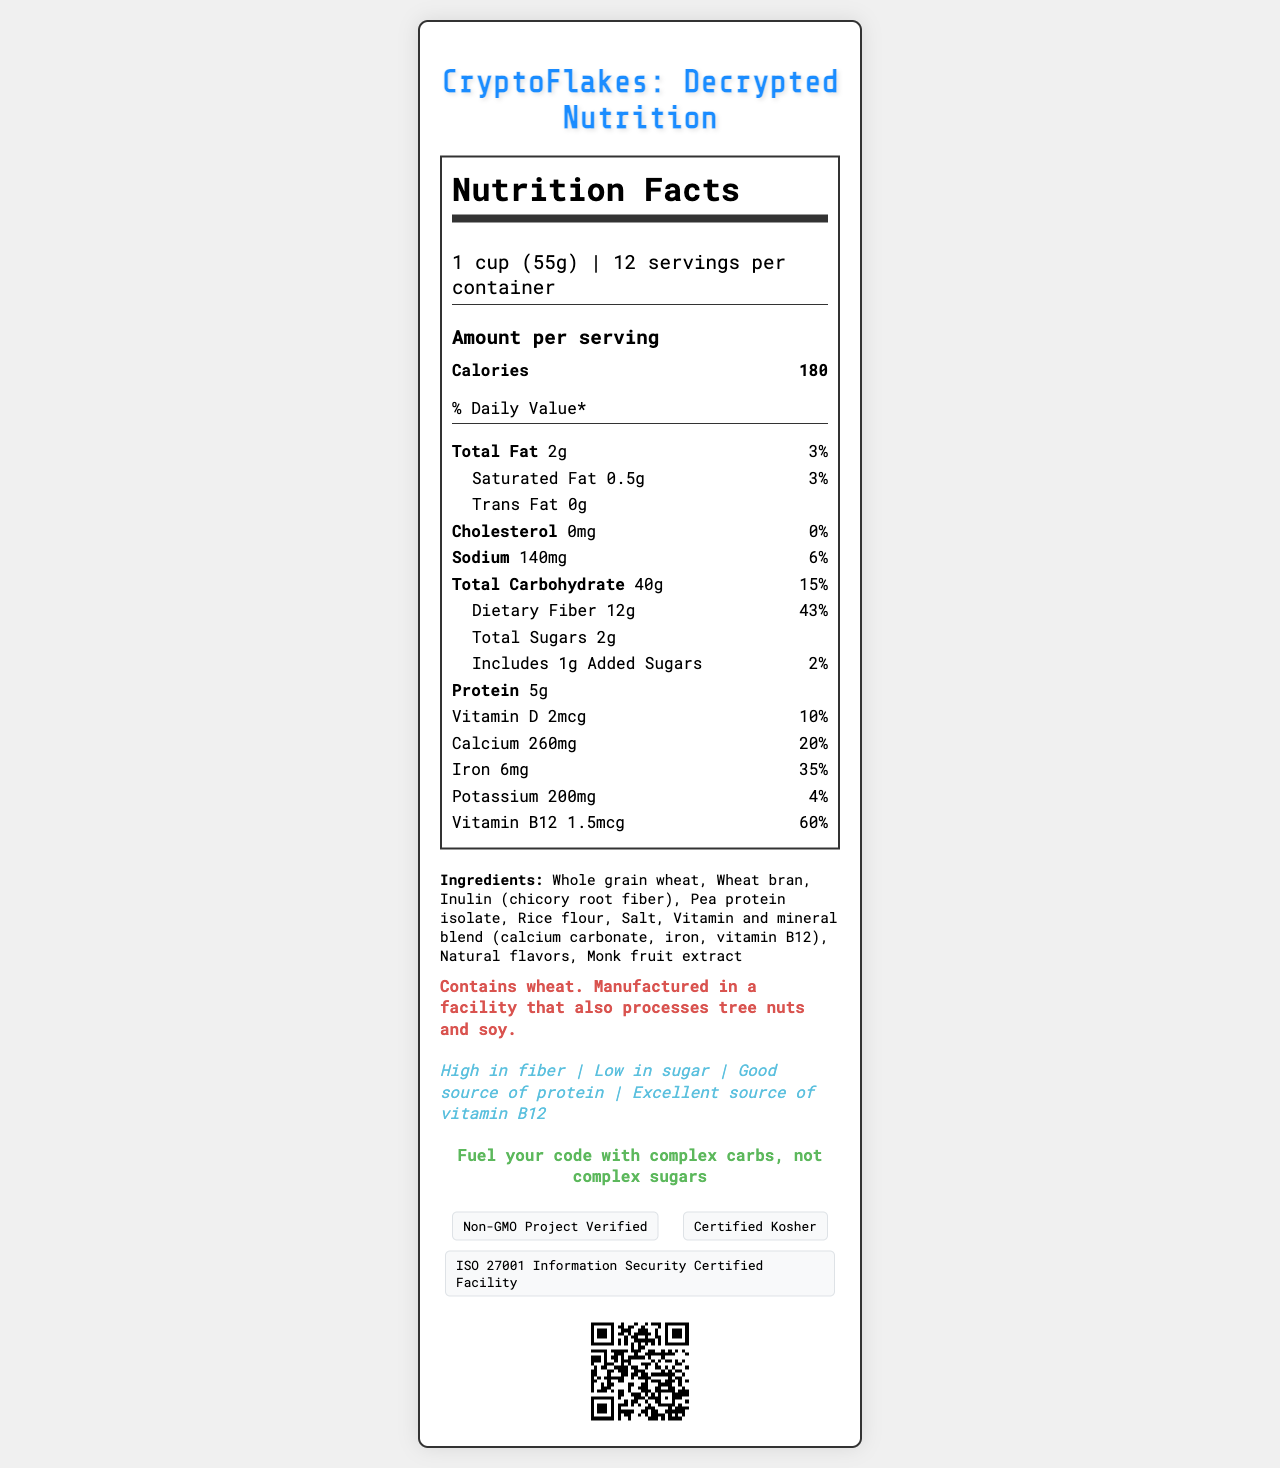what is the serving size of CryptoFlakes? The serving size is listed at the beginning of the nutrition label as "1 cup (55g)".
Answer: 1 cup (55g) how many calories are there per serving? The number of calories per serving is clearly stated right underneath the serving information.
Answer: 180 calories how much protein does one serving of CryptoFlakes contain? The amount of protein per serving is listed under the nutrients section as "Protein 5g".
Answer: 5g what is the daily value percentage for dietary fiber in one serving? The daily value percentage for dietary fiber is listed as "43%" right next to "Dietary Fiber 12g" under total carbohydrate.
Answer: 43% how much calcium is there in one serving? The amount of calcium per serving is mentioned under the nutrients section as "Calcium 260mg (20%)".
Answer: 260mg which ingredient helps boost the fiber content in CryptoFlakes? A. Rice flour B. Inulin (chicory root fiber) C. Pea protein isolate The ingredient list includes "Inulin (chicory root fiber)" which is known to be high in fiber.
Answer: B what certifications does CryptoFlakes have? I. Non-GMO Project Verified II. Certified Organic III. Certified Kosher IV. ISO 27001 Information Security Certified Facility The certifications listed are "Non-GMO Project Verified," "Certified Kosher," and "ISO 27001 Information Security Certified Facility".
Answer: I, III, IV is the cereal low in sugar? The product claims "Low in sugar" and the total sugars per serving is only 2g.
Answer: Yes describe the main idea of the nutrition label for CryptoFlakes The main idea is to give a thorough insight into the nutritional content of CryptoFlakes, emphasizing its low sugar and high fiber content, while also noting its marketing appeal to tech professionals and the cryptographic elements integrated into its design.
Answer: CryptoFlakes is a low-sugar, high-fiber cereal specifically marketed towards tech professionals. It provides comprehensive nutrition information regarding calories, fats, sodium, carbohydrates, fiber, sugars, protein, vitamins, and minerals. The label also highlights ingredient details, allergen information, marketing claims, certifications, and cryptographic design elements. what does the SSL padlock icon represent? The document lists "SSL padlock icon" as a cryptographic design element but doesn't explain its specific significance or representation.
Answer: Not enough information what marketing tagline is used to emphasize optimal mental performance? One of the marketing taglines listed is "Engineered for optimal mental performance".
Answer: Engineered for optimal mental performance what is the daily value percentage for sodium in one serving? The daily value percentage for sodium is listed next to "Sodium 140mg" as "6%".
Answer: 6% does CryptoFlakes contain any tree nuts? The allergen info states "Manufactured in a facility that also processes tree nuts" but does not mention if tree nuts are present in the ingredients themselves.
Answer: Cannot be determined what grain is the primary ingredient? The first ingredient listed is "Whole grain wheat," indicating it is the primary ingredient.
Answer: Whole grain wheat what is the QR code on the document for? A. Product registration B. Company information C. Nutrition details D. Customer feedback The QR code links to "https://www.cryptoflakes.tech/nutrition," hinting it's for nutrition details.
Answer: C 